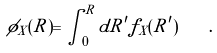<formula> <loc_0><loc_0><loc_500><loc_500>\phi _ { X } ( R ) = \int _ { 0 } ^ { R } d R ^ { \prime } f _ { X } ( R ^ { \prime } ) \quad .</formula> 